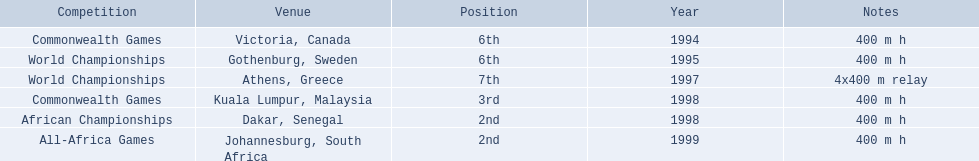What years did ken harder compete in? 1994, 1995, 1997, 1998, 1998, 1999. For the 1997 relay, what distance was ran? 4x400 m relay. 